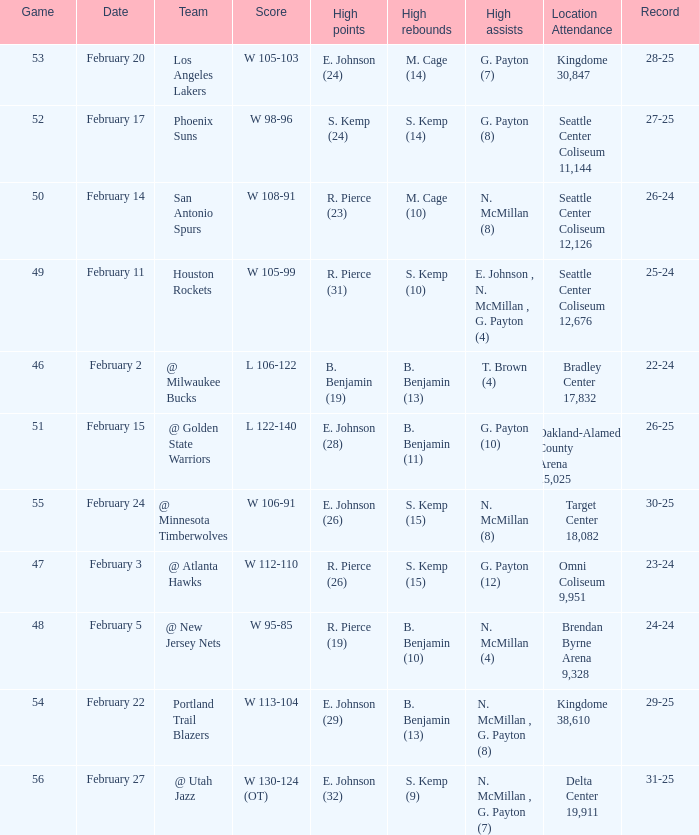Who had the high points when the score was w 112-110? R. Pierce (26). 